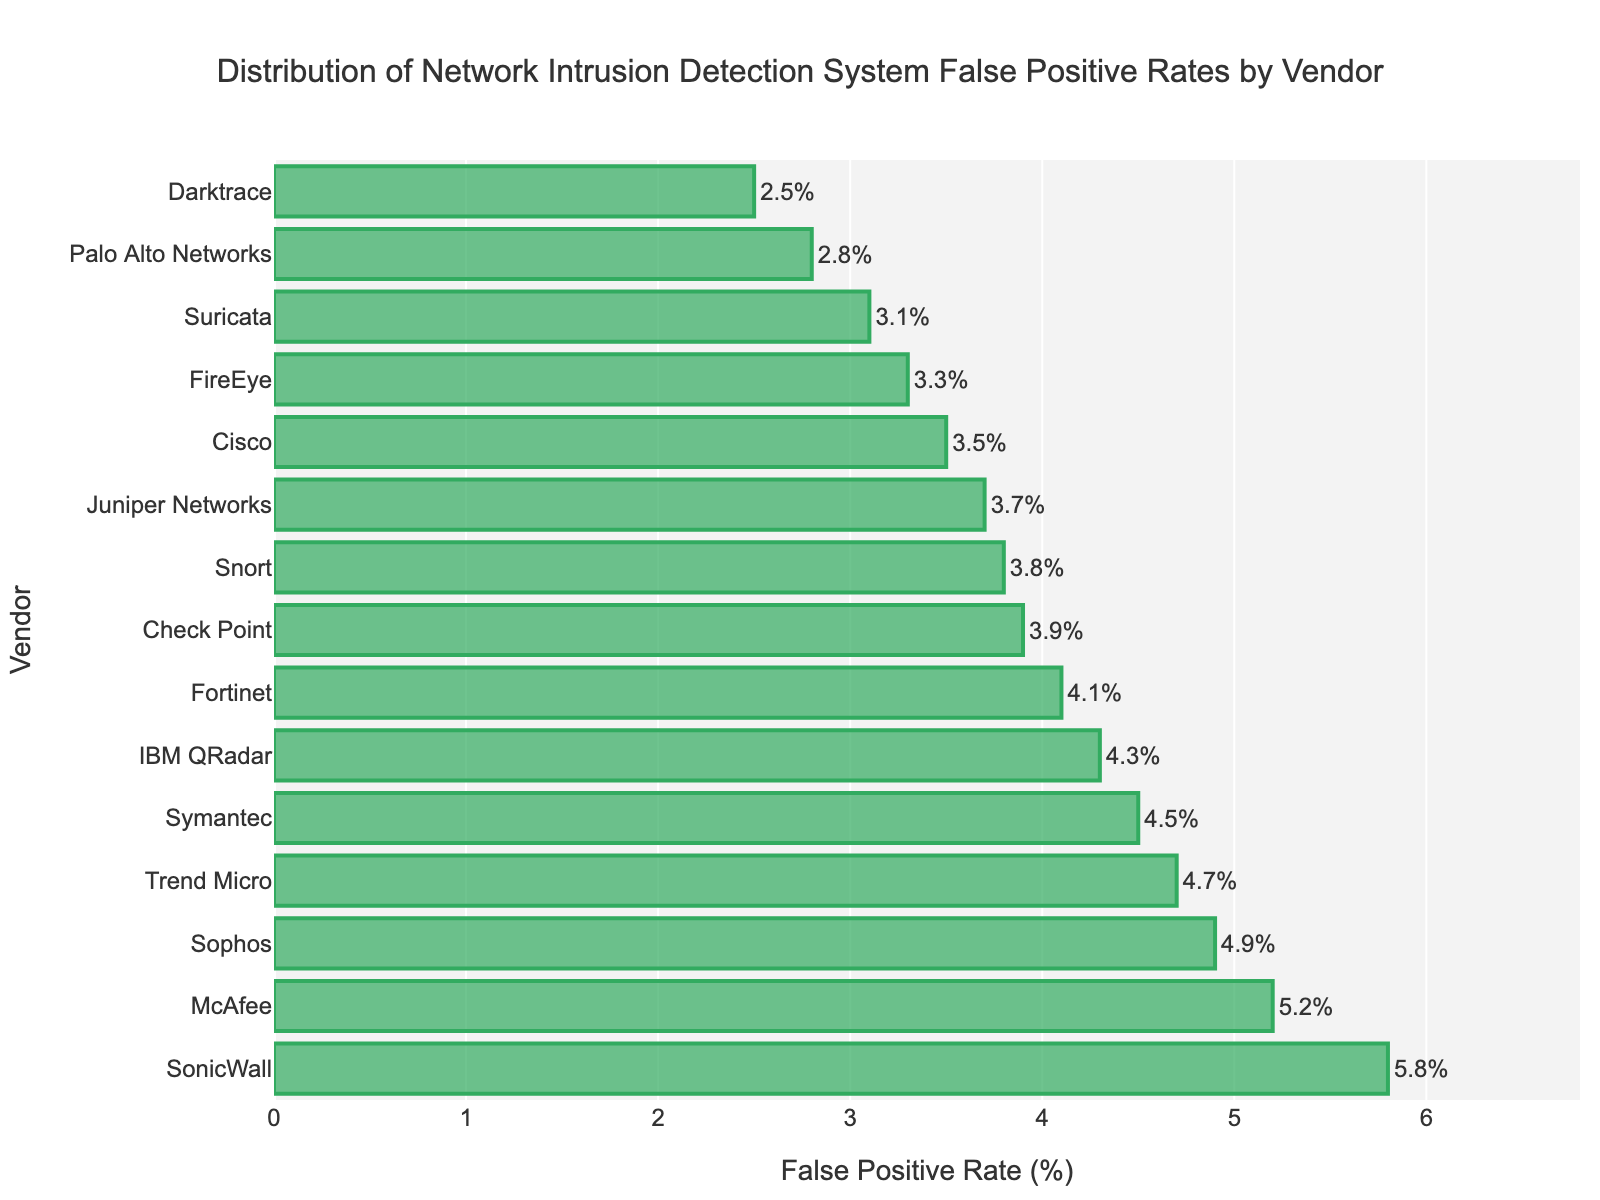What's the false positive rate for Palo Alto Networks? Find the bar labeled "Palo Alto Networks" and read the false positive rate at the end of the bar.
Answer: 2.8% Which vendor has the highest false positive rate? Identify the longest bar in the chart to find the vendor with the highest false positive rate.
Answer: SonicWall Which vendors have a false positive rate lower than 3%? Find the bars with rates less than 3% and note the corresponding vendors.
Answer: Palo Alto Networks, Darktrace What is the difference in false positive rate between Symantec and Trend Micro? Locate the bars for Symantec and Trend Micro, subtract the smaller rate from the larger one (4.7% - 4.5%).
Answer: 0.2% What is the average false positive rate of the top three vendors with the highest false positive rates? Find the three longest bars, sum their rates and divide by 3 ((5.8% + 5.2% + 4.9%) / 3).
Answer: 5.3% How does the false positive rate of Check Point compare to Suricata? Compare the lengths of the bars for Check Point and Suricata. Check Point's rate (3.9%) is higher than Suricata's rate (3.1%).
Answer: Higher Are there more vendors with a false positive rate above 4% than below 4%? Count the vendors with rates above and below 4%. There are 7 vendors above 4% and 8 vendors below 4%.
Answer: No By how much percentage is SonicWall's false positive rate higher than the average rate of all vendors? Calculate the overall average rate (sum of all rates divided by the number of vendors), and then find the difference (SonicWall's rate - average rate).
Answer: SonicWall's rate is higher by approximately 1.84% What's the median false positive rate among all vendors? Arrange the rates in ascending order and find the middle value. With 15 vendors, the median is the 8th value in the sorted list.
Answer: 4.1% 